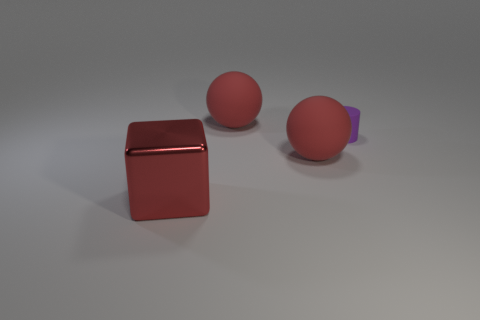Add 3 rubber cylinders. How many objects exist? 7 Subtract 1 balls. How many balls are left? 1 Subtract all small cylinders. Subtract all big red cubes. How many objects are left? 2 Add 1 large red spheres. How many large red spheres are left? 3 Add 1 red matte balls. How many red matte balls exist? 3 Subtract 0 cyan blocks. How many objects are left? 4 Subtract all cylinders. How many objects are left? 3 Subtract all green cylinders. Subtract all brown balls. How many cylinders are left? 1 